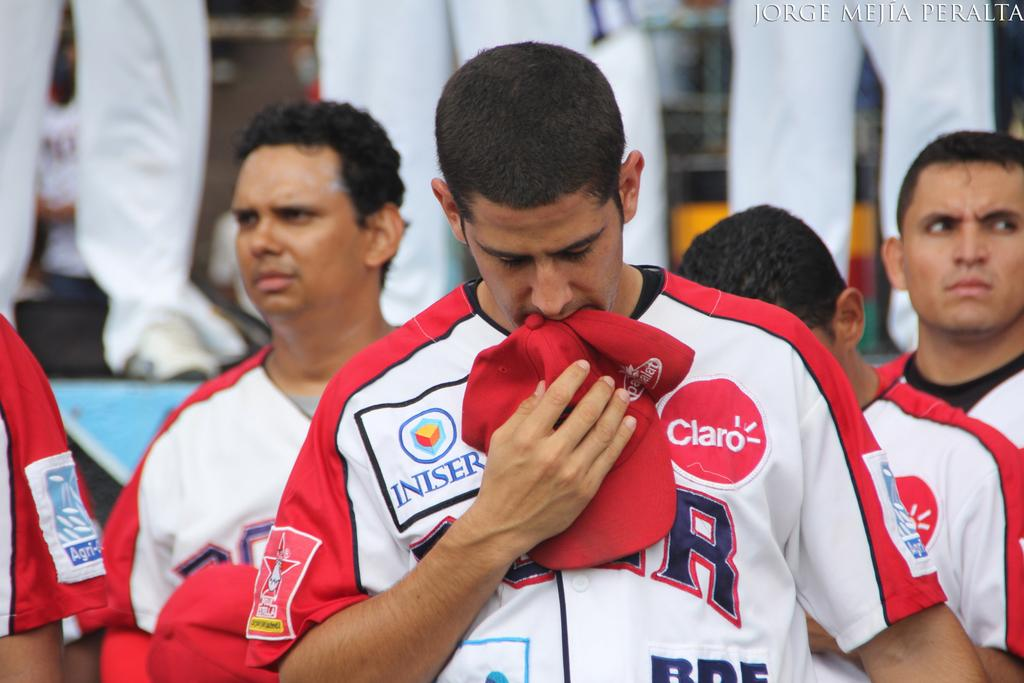Who can be seen in the image? There are people in the image. Can you describe the man in the center of the image? A man is standing in the center of the image. What is the man holding in the image? The man is holding a cap. How many rings can be seen on the man's finger in the image? There are no rings visible on the man's finger in the image. Can you describe the romantic interaction between the people in the image? There is no romantic interaction depicted in the image; it only shows a man standing in the center holding a cap. 